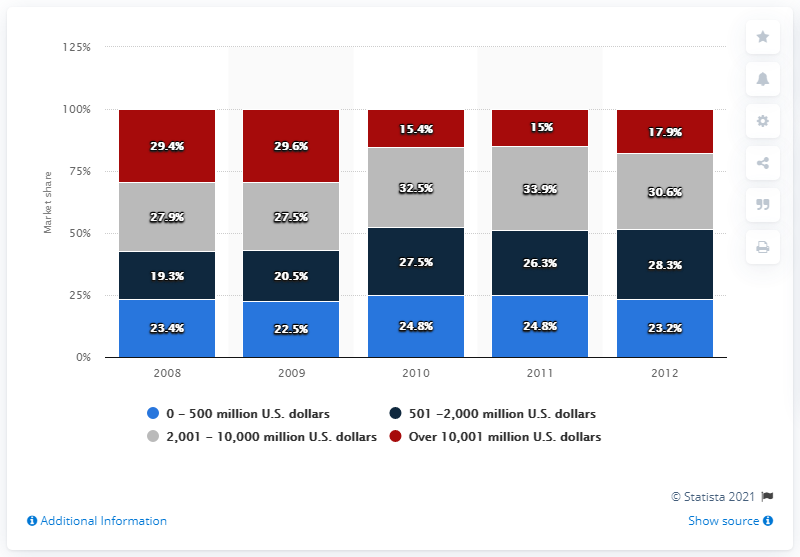Outline some significant characteristics in this image. The difference between deals over 10001 million US dollars and 2001-10000 million US dollars was maximum in 2011. In 2008, deals worth over 100,000 million US dollars occurred, and of these deals, 29.4% happened. In 2012, approximately 28.3% of the deals that were made were valued between 501 and 2,000 million dollars. 